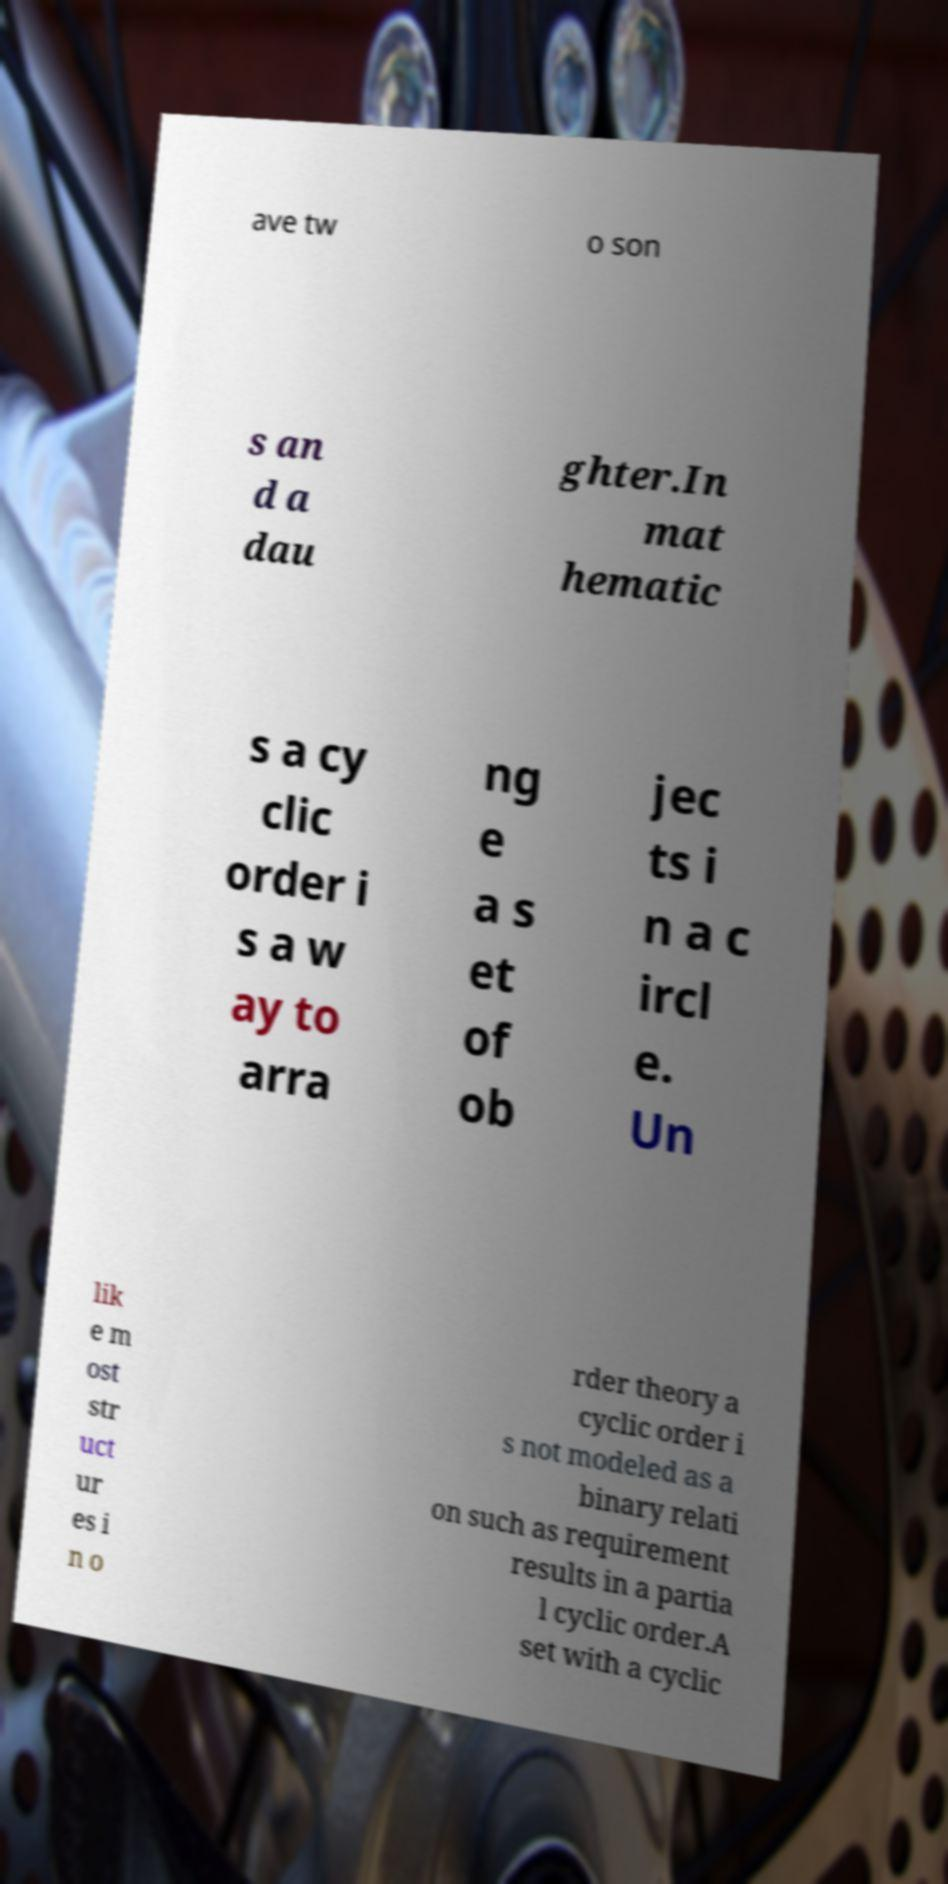Please identify and transcribe the text found in this image. ave tw o son s an d a dau ghter.In mat hematic s a cy clic order i s a w ay to arra ng e a s et of ob jec ts i n a c ircl e. Un lik e m ost str uct ur es i n o rder theory a cyclic order i s not modeled as a binary relati on such as requirement results in a partia l cyclic order.A set with a cyclic 